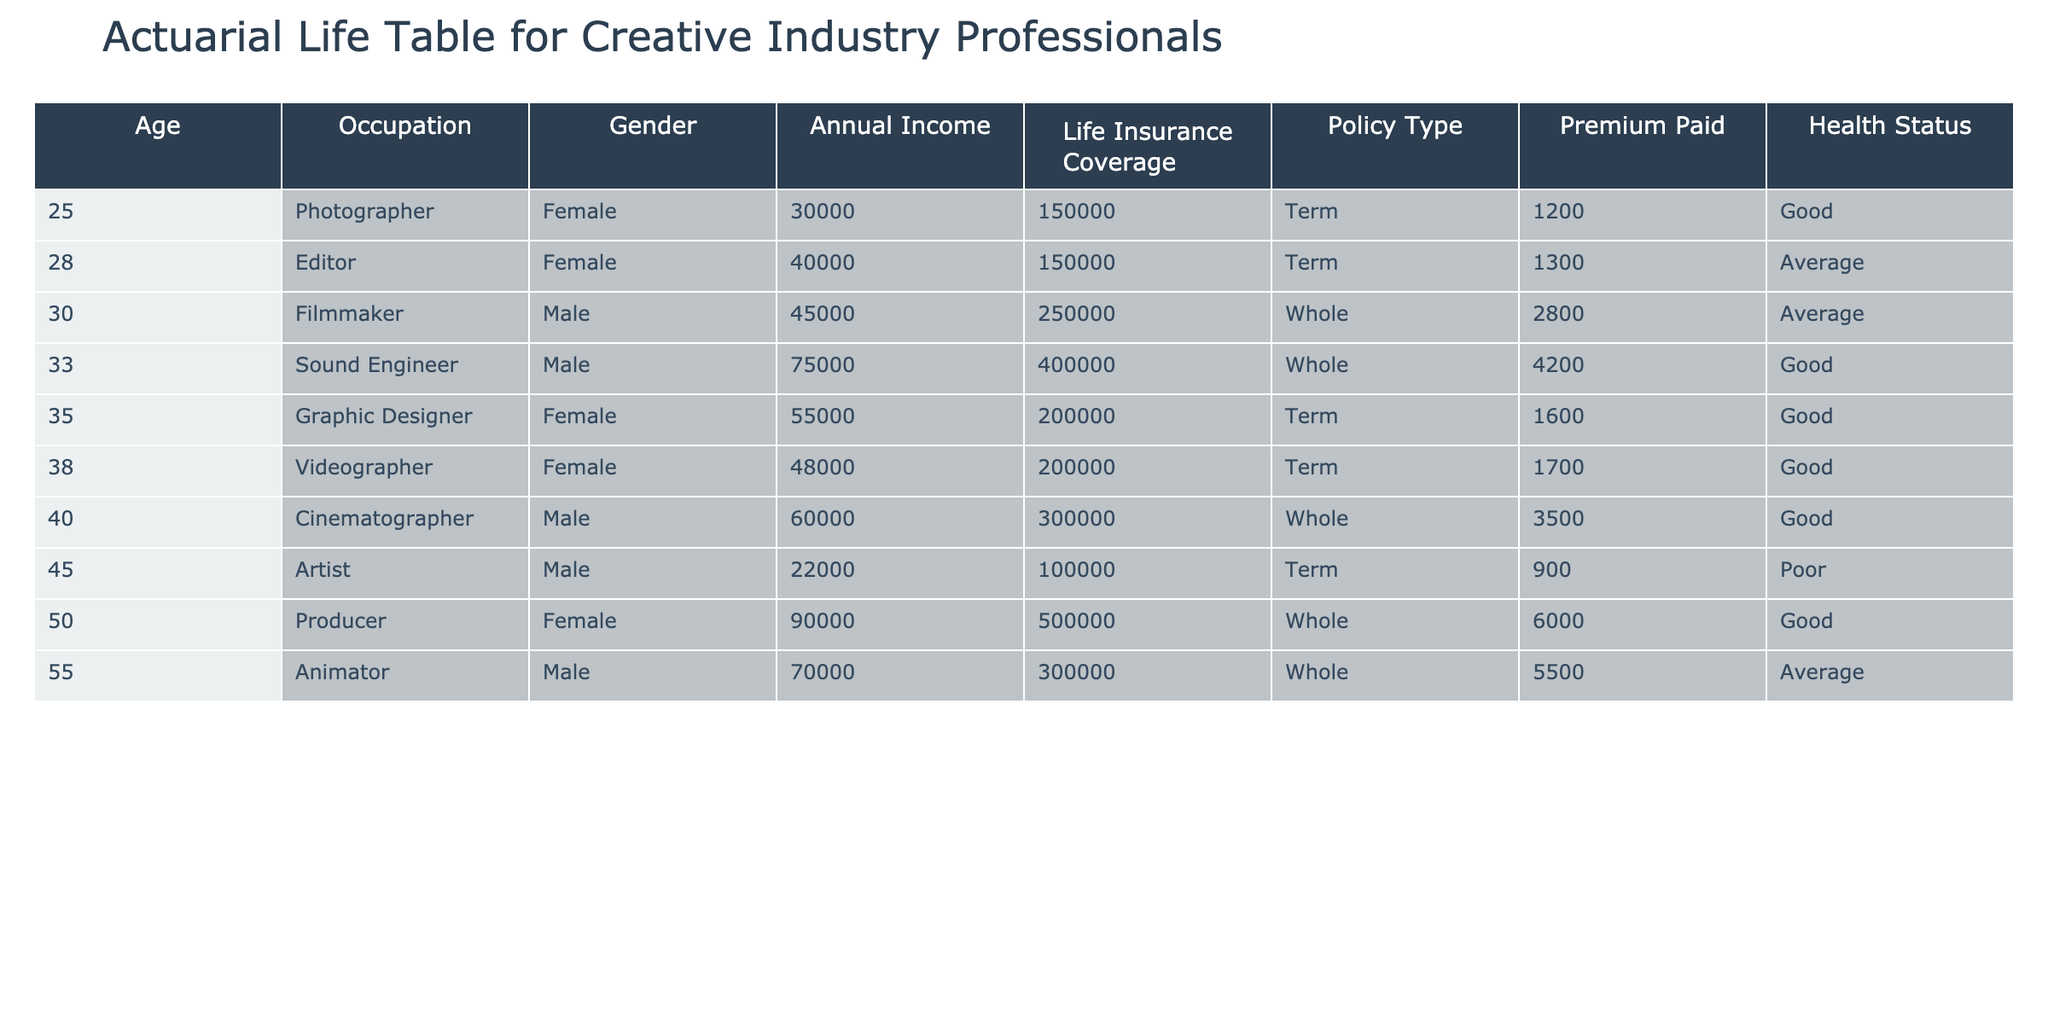What is the life insurance coverage for the 40-year-old male Cinematographer? Referring to the table, the life insurance coverage for the 40-year-old male Cinematographer is found in the respective row under the "Life Insurance Coverage" column. It shows 300,000.
Answer: 300000 How many individuals in the table have a "Good" health status? Counting the entries in the "Health Status" column, we see that the individuals with a "Good" health status are those at ages 25, 35, 40, 33, 50, and 38, making a total of 6 individuals.
Answer: 6 Are there any individuals with a "Poor" health status in the table? By inspecting the "Health Status" column, there is 1 individual, the 45-year-old male Artist, who has a "Poor" health status.
Answer: Yes What is the total annual income of individuals listed in the table? To find the total, we sum the values in the "Annual Income" column: 30000 + 45000 + 55000 + 60000 + 40000 + 75000 + 90000 + 22000 + 48000 + 70000 = 405000.
Answer: 405000 What is the average premium paid for the life insurance among individuals in the table? To calculate the average, sum the premium values: 1200 + 2800 + 1600 + 3500 + 1300 + 4200 + 6000 + 900 + 1700 + 5500 = 25100. There are 10 individuals, so the average is 25100 / 10 = 2510.
Answer: 2510 Which policy type has the most coverage amount in the table? By examining the "Life Insurance Coverage" column against the "Policy Type," we find that the highest amount of coverage is for a Whole policy, provided to the 50-year-old female Producer with 500000 coverage.
Answer: Whole What is the difference in life insurance coverage between the oldest and youngest individuals? The youngest individual is the 25-year-old female Photographer with a coverage of 150000. The oldest individual is the 55-year-old male Animator with a coverage of 300000. The difference is 300000 - 150000 = 150000.
Answer: 150000 Is the average life insurance coverage for females higher than for males? First, we calculate the average for females: (150000 + 200000 + 150000 + 500000 + 200000) / 5 = 240000. For males, (250000 + 300000 + 400000 + 100000 + 300000) / 5 = 270000. Since 240000 < 270000, the answer is No.
Answer: No What percentage of the individuals have Whole policies compared to the total number of individuals? There are 4 Whole policies (Filmmaker, Cinematographer, Sound Engineer, Producer). With a total of 10 individuals, the percentage is (4 / 10) * 100 = 40%.
Answer: 40% 